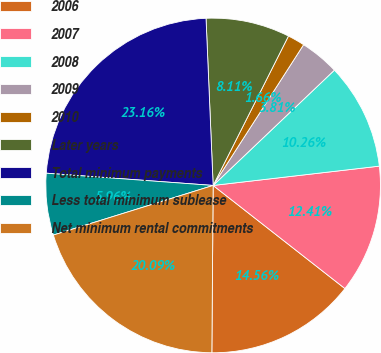<chart> <loc_0><loc_0><loc_500><loc_500><pie_chart><fcel>2006<fcel>2007<fcel>2008<fcel>2009<fcel>2010<fcel>Later years<fcel>Total minimum payments<fcel>Less total minimum sublease<fcel>Net minimum rental commitments<nl><fcel>14.56%<fcel>12.41%<fcel>10.26%<fcel>3.81%<fcel>1.66%<fcel>8.11%<fcel>23.16%<fcel>5.96%<fcel>20.09%<nl></chart> 